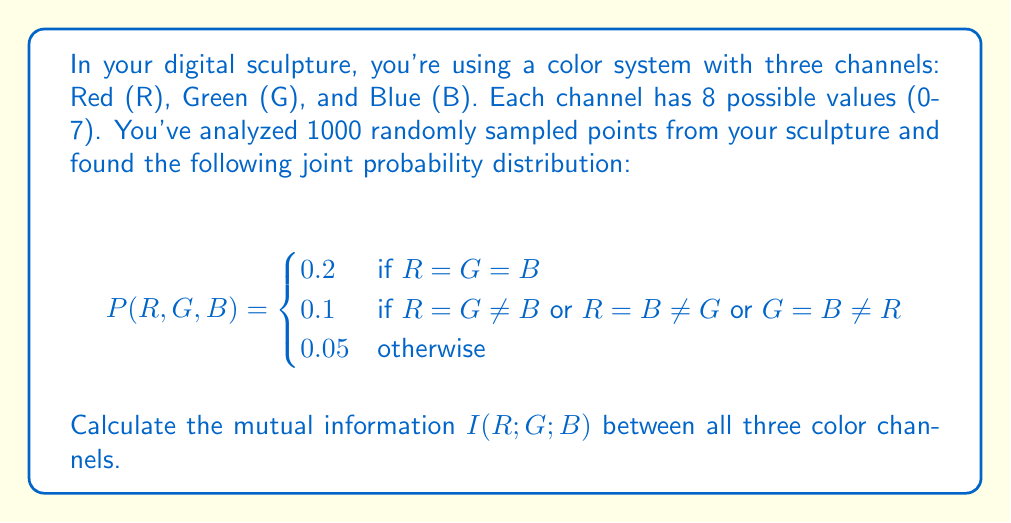Can you answer this question? To calculate the mutual information between three variables, we'll use the following formula:

$$I(R;G;B) = I(R;G) - I(R;G|B)$$

Where $I(R;G)$ is the mutual information between R and G, and $I(R;G|B)$ is the conditional mutual information of R and G given B.

Step 1: Calculate marginal probabilities
First, we need to calculate the marginal probabilities for each channel:

$$P(R=i) = P(G=i) = P(B=i) = 0.2 + 2(0.1) + 5(0.05) = 0.55$$

for any value $i$ from 0 to 7.

Step 2: Calculate joint probabilities
$$P(R=G) = 8(0.2) + 8(0.1) = 2.4$$
$$P(R=B) = P(G=B) = 2.4$$

Step 3: Calculate $I(R;G)$
$$I(R;G) = \sum_{r,g} P(R=r, G=g) \log_2 \frac{P(R=r, G=g)}{P(R=r)P(G=g)}$$

$$I(R;G) = 8(0.2 \log_2 \frac{0.2}{0.55^2}) + 8(0.1 \log_2 \frac{0.1}{0.55^2}) + 48(0.05 \log_2 \frac{0.05}{0.55^2})$$

$$I(R;G) \approx 0.5623 \text{ bits}$$

Step 4: Calculate $I(R;G|B)$
$$I(R;G|B) = \sum_{r,g,b} P(R=r, G=g, B=b) \log_2 \frac{P(R=r, G=g | B=b)}{P(R=r | B=b)P(G=g | B=b)}$$

$$I(R;G|B) = 8(0.2 \log_2 \frac{0.2}{0.3^2}) + 16(0.1 \log_2 \frac{0.1}{0.3 \cdot 0.15}) + 48(0.05 \log_2 \frac{0.05}{0.15^2})$$

$$I(R;G|B) \approx 0.2811 \text{ bits}$$

Step 5: Calculate $I(R;G;B)$
$$I(R;G;B) = I(R;G) - I(R;G|B)$$
$$I(R;G;B) = 0.5623 - 0.2811 = 0.2812 \text{ bits}$$
Answer: The mutual information $I(R;G;B)$ between all three color channels is approximately 0.2812 bits. 